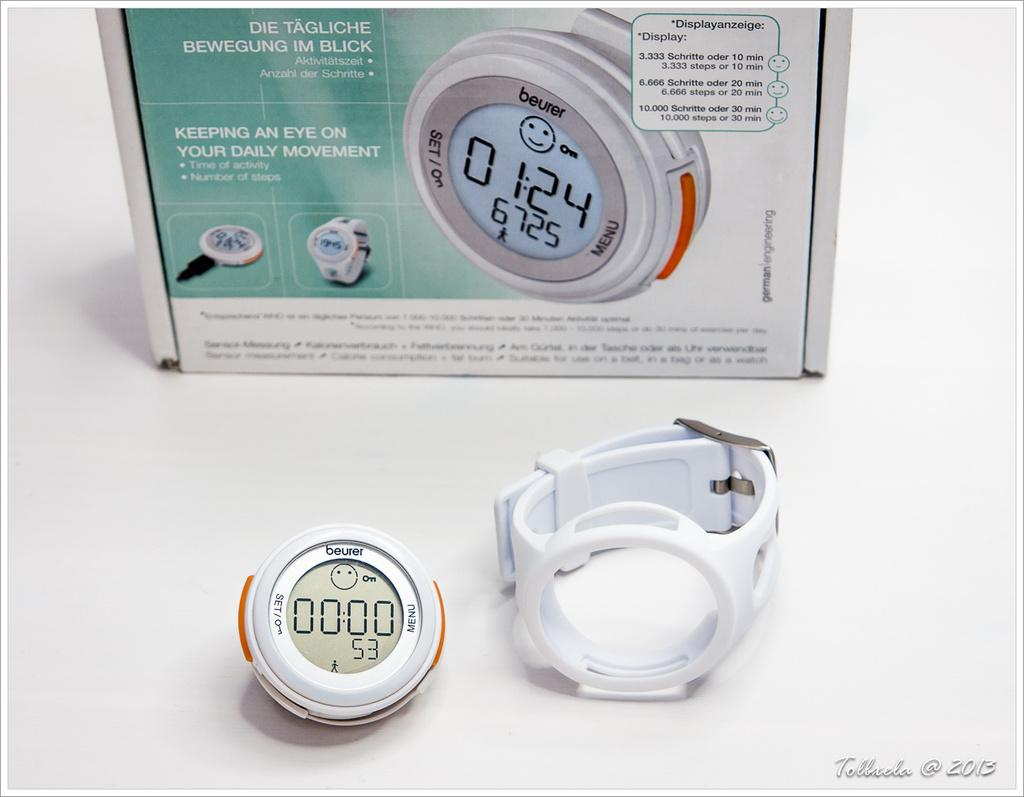<image>
Offer a succinct explanation of the picture presented. A pedometer of the brand beurer is sitting in front of the box it came in. 